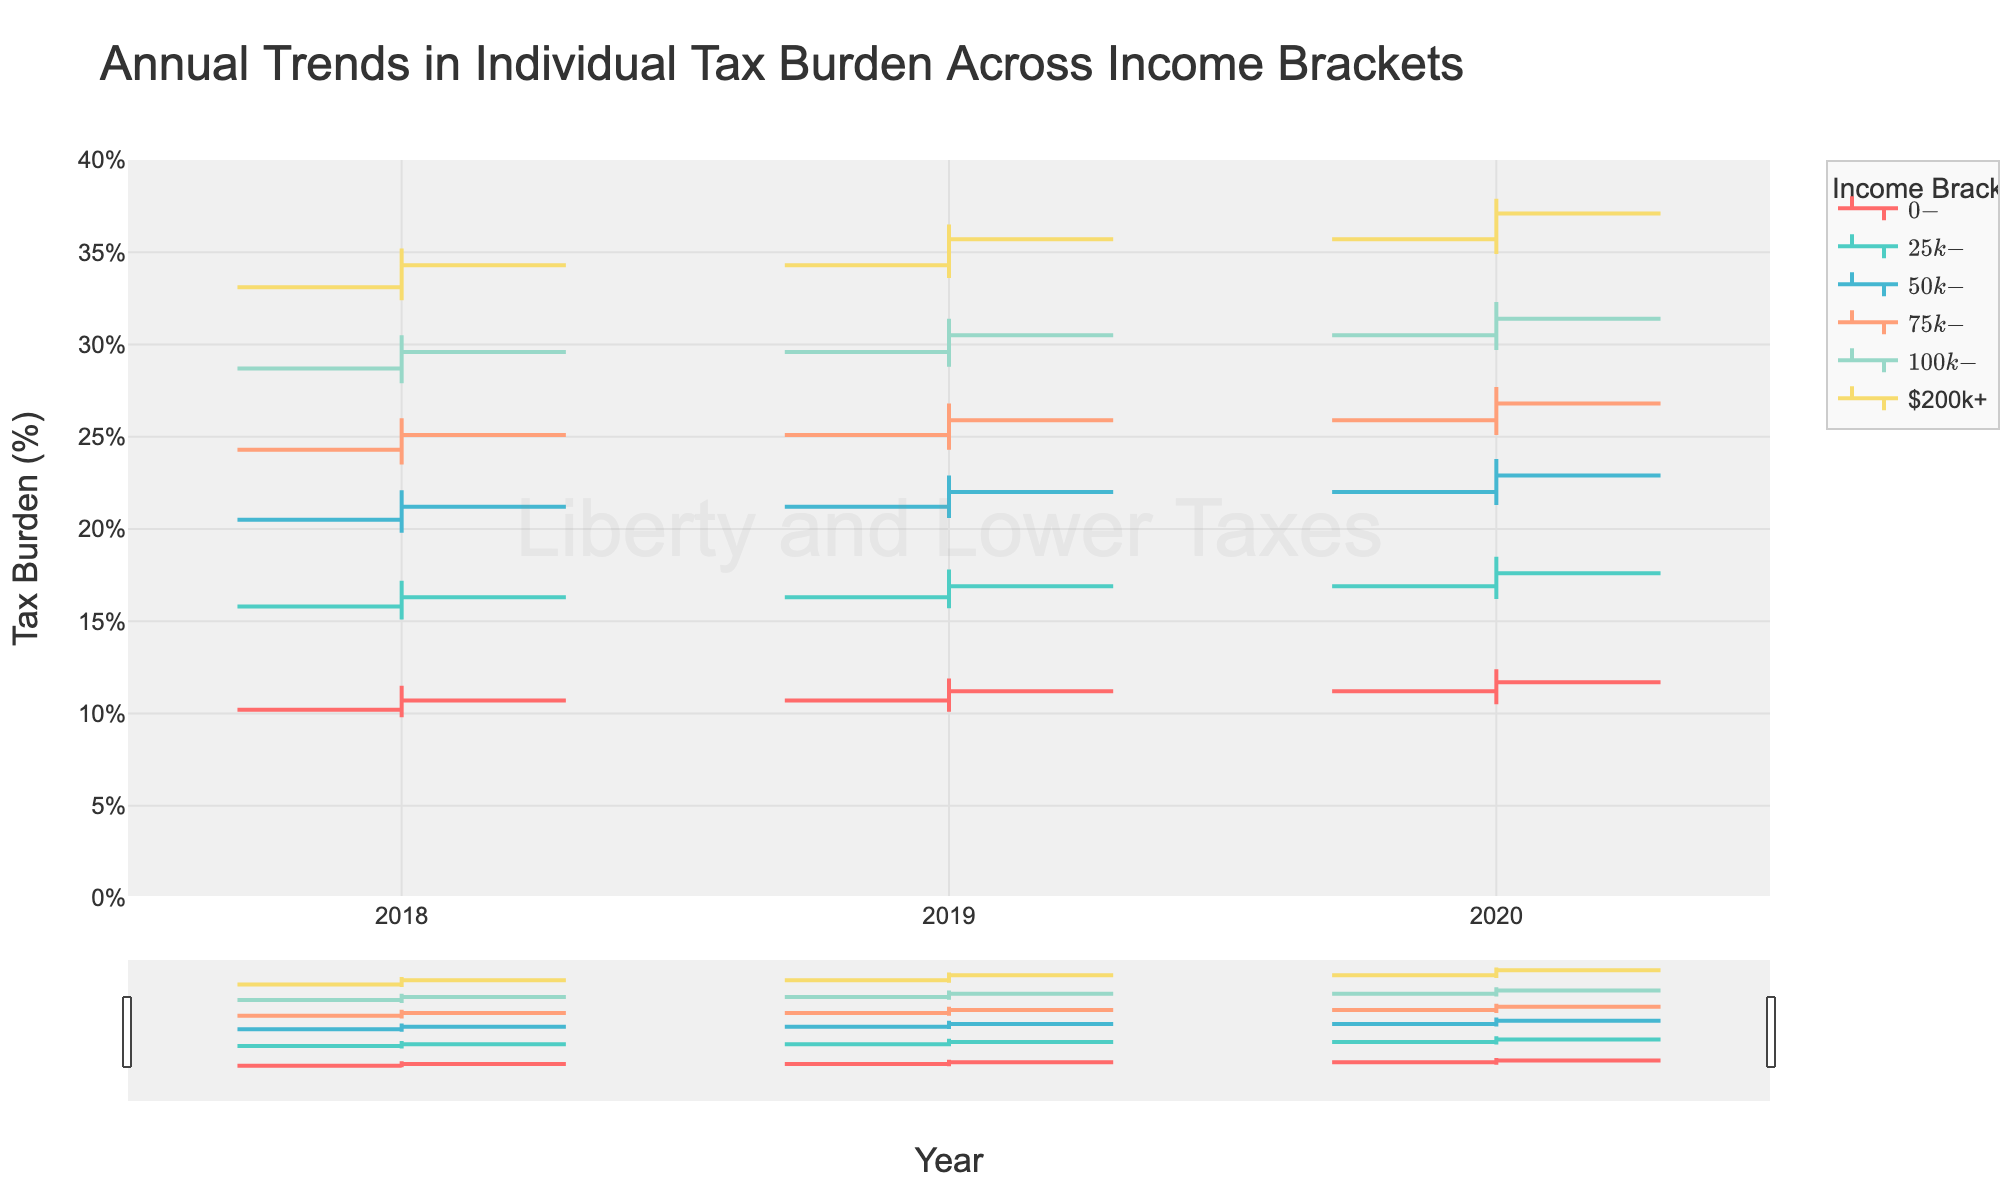What is the title of the chart? The title is usually located at the top of the chart, and it provides the main topic or description of the data being presented. Here, the title is "Annual Trends in Individual Tax Burden Across Income Brackets."
Answer: Annual Trends in Individual Tax Burden Across Income Brackets Which income bracket had the lowest tax burden in 2019? To find this, you need to look at all the income brackets for 2019 and identify the lowest "Lowest" percentage value among them. For 2019, the $0-$25k bracket had the lowest tax burden of 10.1%.
Answer: $0-$25k What was the closing tax burden for the $200k+ income bracket in 2020? Locate the data for the $200k+ income bracket in 2020 and find the value listed under the "Closing" column. It shows a tax burden of 37.1%.
Answer: 37.1% Between 2018 and 2020, did the tax burden generally increase or decrease for the $50k-$75k income bracket? To determine this, compare the "Opening" value in 2018 with the "Closing" value in 2020. The values are 20.5% in 2018 and 22.9% in 2020, indicating an increase.
Answer: Increase Which year had the highest tax burden for the $75k-$100k income bracket? Check the "Highest" value for the $75k-$100k bracket across all years. The data shows 26.0% in 2018, 26.8% in 2019, and 27.7% in 2020. Thus, 2020 had the highest tax burden.
Answer: 2020 What is the average opening tax burden for all income brackets in 2018? Add the opening values for all income brackets in 2018 and divide by the number of brackets. The sum is (10.2 + 15.8 + 20.5 + 24.3 + 28.7 + 33.1) = 132.6. There are 6 brackets, so the average is 132.6 / 6 = 22.1%.
Answer: 22.1% Compare the highest tax burden of $25k-$50k in 2018 and 2020. Which is higher and by how much? Identify the highest values for this bracket in 2018 and 2020. They are 17.2% in 2018 and 18.5% in 2020, respectively. The difference is 18.5% - 17.2% = 1.3%.
Answer: 2020 by 1.3% What was the trend in the closing tax burden for the $0-$25k income bracket from 2018 to 2020? Increase, decrease, or constant? Look at the closing values for the $0-$25k bracket for each year: 10.7% in 2018, 11.2% in 2019, and 11.7% in 2020. The trend shows an increase each year.
Answer: Increase In which year did the $100k-$200k income bracket experience the lowest tax burden? Check the "Lowest" value for the $100k-$200k bracket for each year. The values are 27.9% in 2018, 28.8% in 2019, and 29.7% in 2020. The lowest point is in 2018 at 27.9%.
Answer: 2018 